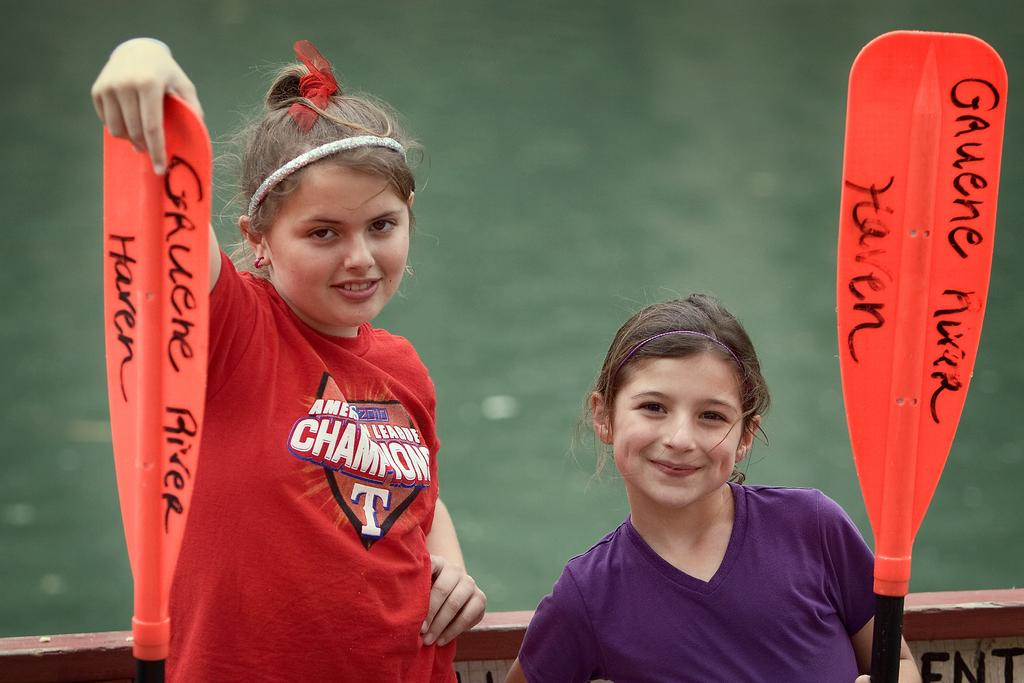<image>
Offer a succinct explanation of the picture presented. Two girls holding paddles from the Gauene River Haven 